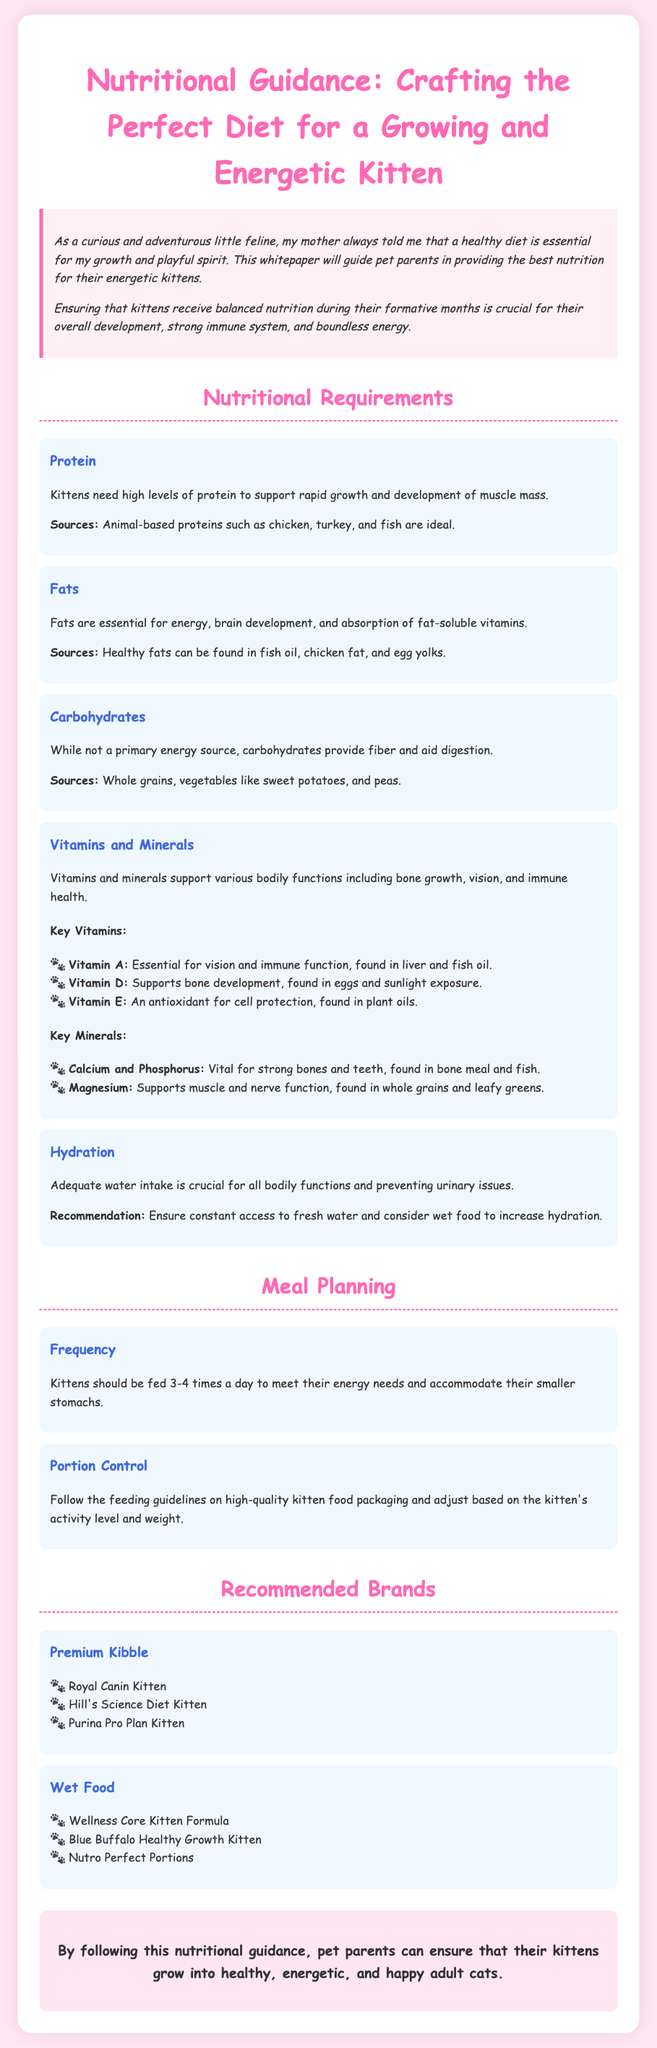What are the protein sources for kittens? The document states that animal-based proteins such as chicken, turkey, and fish are ideal sources of protein for kittens.
Answer: chicken, turkey, and fish How many times a day should kittens be fed? The document recommends feeding kittens 3-4 times a day to meet their energy needs.
Answer: 3-4 times What is the importance of fats in a kitten's diet? According to the document, fats are essential for energy, brain development, and absorption of fat-soluble vitamins.
Answer: energy, brain development, absorption of fat-soluble vitamins Which vitamin supports bone development? The document mentions that Vitamin D supports bone development in kittens.
Answer: Vitamin D Name a recommended premium kibble brand for kittens. The document lists "Royal Canin Kitten" as one of the recommended premium kibble brands.
Answer: Royal Canin Kitten What are the key minerals for strong bones and teeth? The document indicates that Calcium and Phosphorus are vital for strong bones and teeth.
Answer: Calcium and Phosphorus What role do carbohydrates play in a kitten's diet? It states that carbohydrates provide fiber and aid digestion in a kitten's diet.
Answer: fiber and aid digestion What should be ensured regarding hydration? The document emphasizes the need for constant access to fresh water and suggests wet food to increase hydration.
Answer: constant access to fresh water Which food type is beneficial for increasing hydration in kittens? The document suggests considering wet food to increase hydration for kittens.
Answer: wet food 